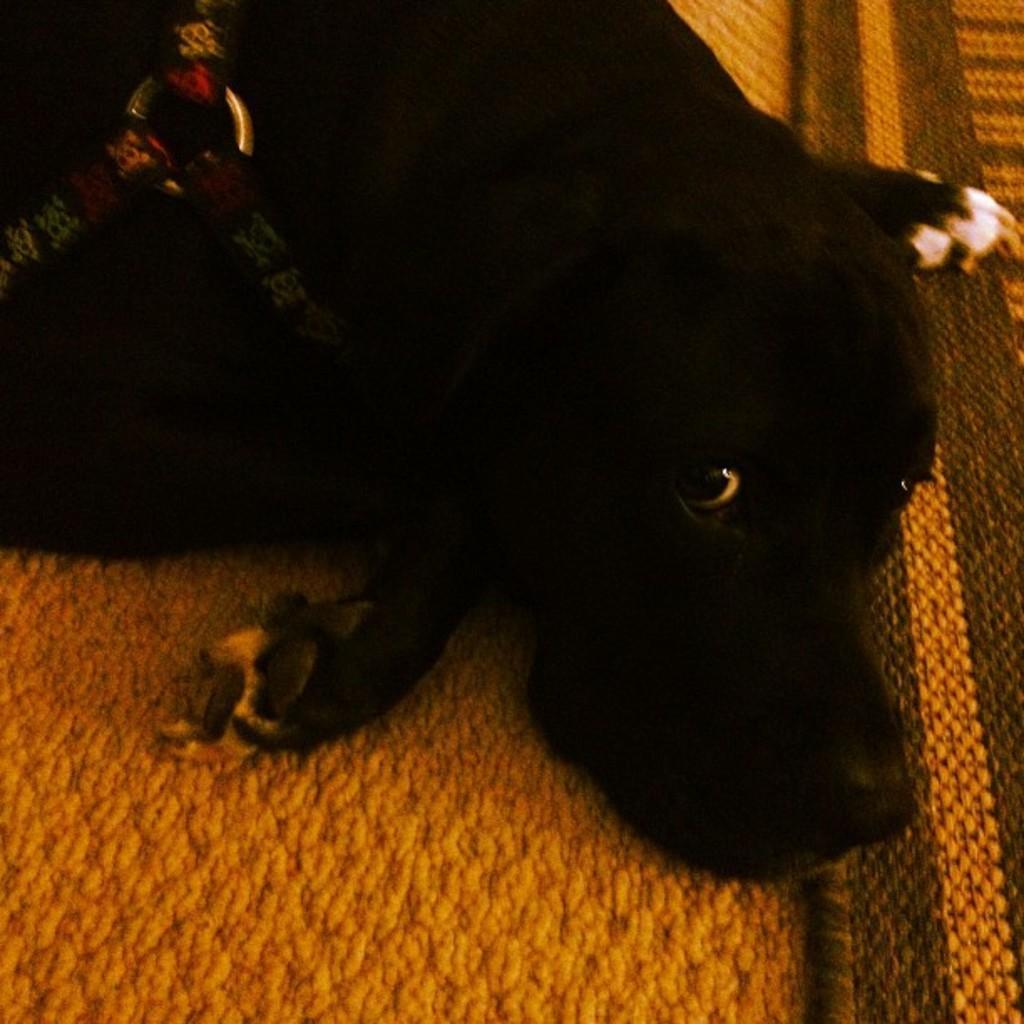Could you give a brief overview of what you see in this image? In this picture, we see a dog in black color is lying on the carpet and the carpet is in orange color. 